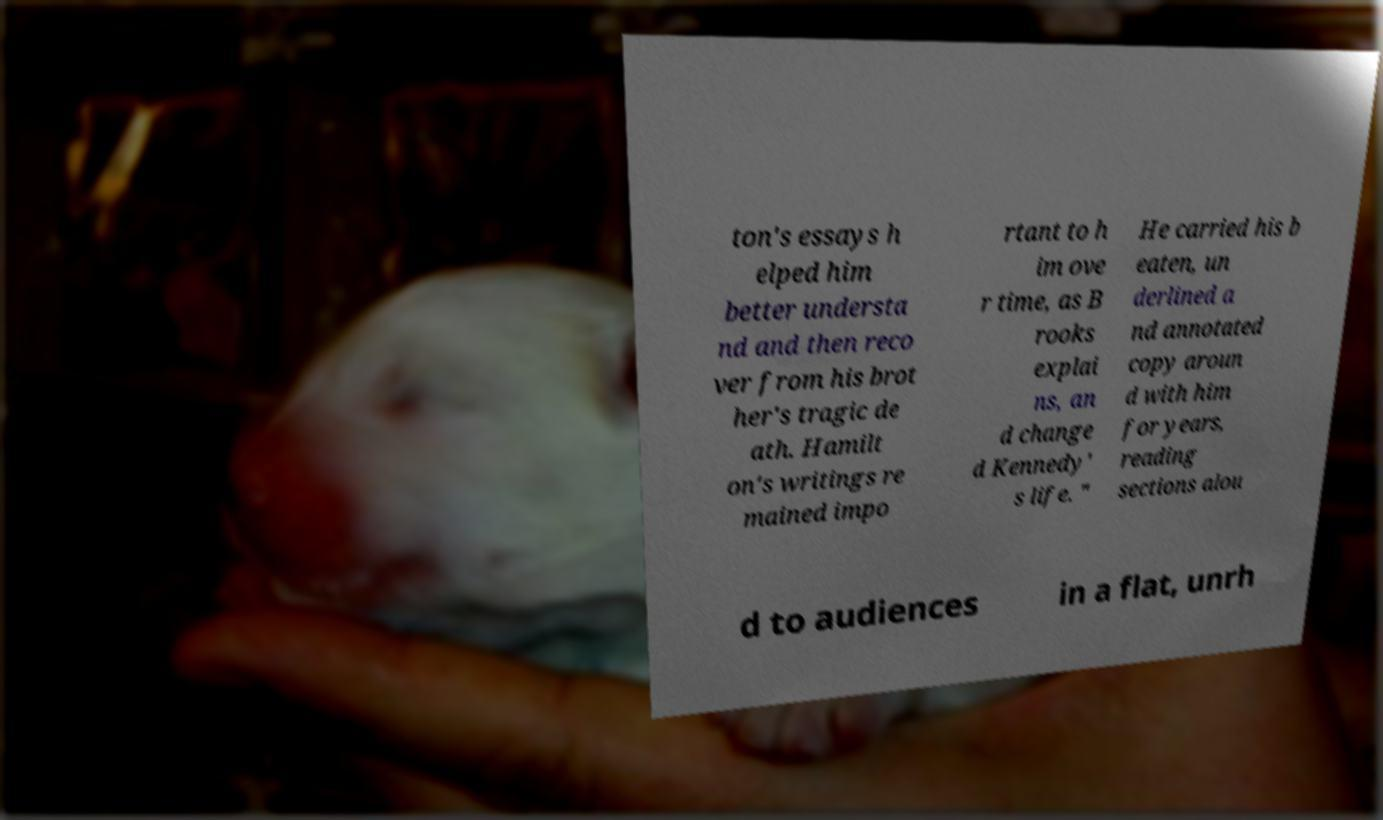Can you accurately transcribe the text from the provided image for me? ton's essays h elped him better understa nd and then reco ver from his brot her's tragic de ath. Hamilt on's writings re mained impo rtant to h im ove r time, as B rooks explai ns, an d change d Kennedy' s life. " He carried his b eaten, un derlined a nd annotated copy aroun d with him for years, reading sections alou d to audiences in a flat, unrh 